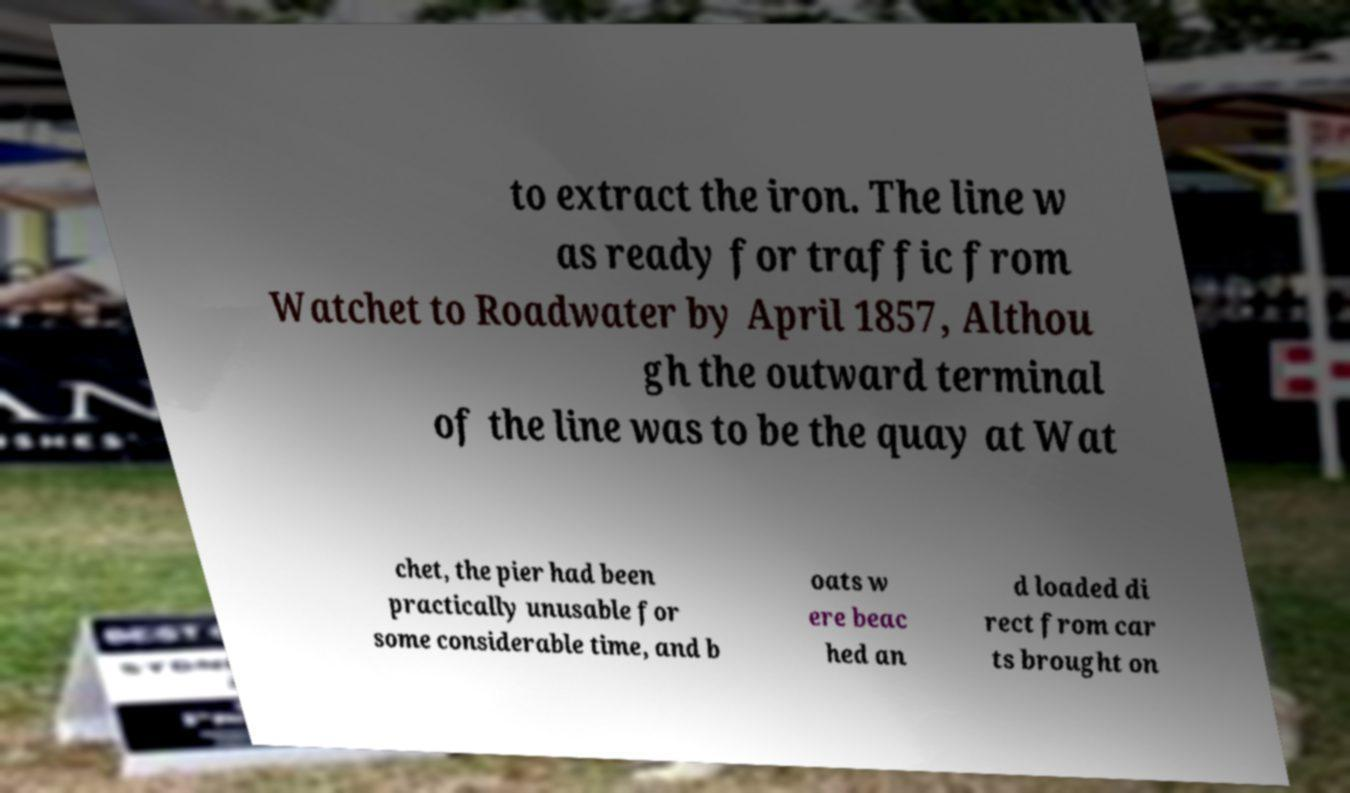Please identify and transcribe the text found in this image. to extract the iron. The line w as ready for traffic from Watchet to Roadwater by April 1857, Althou gh the outward terminal of the line was to be the quay at Wat chet, the pier had been practically unusable for some considerable time, and b oats w ere beac hed an d loaded di rect from car ts brought on 